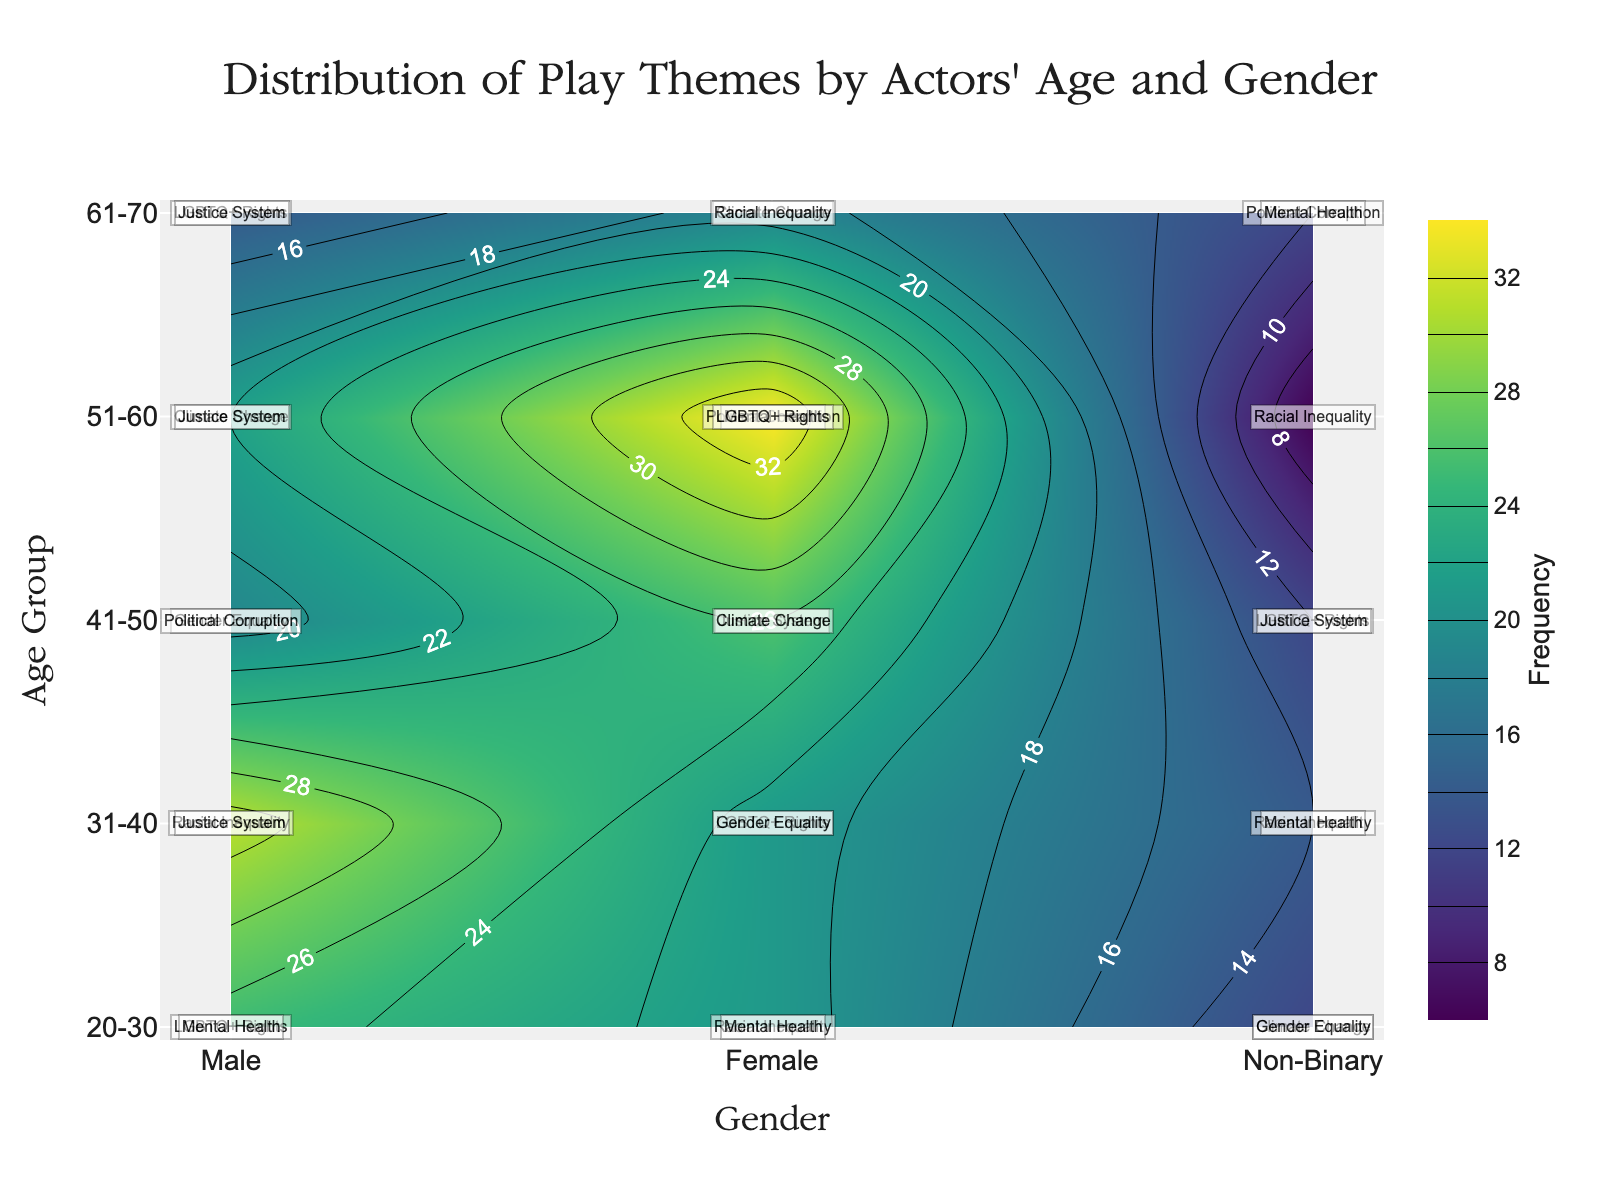What is the title of the plot? The plot title is typically prominently displayed at the top-center of the figure. Based on the provided code, the title is 'Distribution of Play Themes by Actors' Age and Gender'.
Answer: Distribution of Play Themes by Actors' Age and Gender Which age groups are displayed on the y-axis? The y-axis shows the age groups explicitly, which are '20-30', '31-40', '41-50', '51-60', and '61-70'.
Answer: '20-30', '31-40', '41-50', '51-60', '61-70' Which gender has the highest frequency in the '31-40' age group? Looking at the contour plot for the '31-40' age group on the y-axis, the colors represent frequency intensity, and 'Male' (x-axis) should show the brightest color, matching the highest frequency.
Answer: Male What theme is represented by the annotation in the '20-30' age group and 'Non-Binary' gender? The specific annotation for '20-30' age group intersecting with 'Non-Binary' gender would show the theme that is written there. The annotation is 'Climate Change'.
Answer: Climate Change Which theme is the most frequent among 'Female' actors in the '51-60' age group? From the annotations, look at the '51-60' age group for the 'Female' column. The theme with the highest frequency, as per the provided data, will be obvious.
Answer: Political Corruption What is the frequency difference between 'Male' and 'Female' actors within the '41-50' age group? Compare the color intensity or numerical annotations for 'Male' and 'Female' within the '41-50' age group. According to the data, it's (10+9) - (14+12) = 19 - 26 = -7.
Answer: -7 Which gender in the '61-70' age group discusses the 'Political Corruption' theme? Check the '61-70' age group on the y-axis and look for 'Political Corruption' in the annotations. The annotation indicates it's discussed by 'Non-Binary' gender.
Answer: Non-Binary How does the 'Climate Change' theme frequency compare between 'Male' and 'Female' in the '51-60' age group? By referring to the contours and annotations, compare the frequency values. 'Male' has 8 and 'Female' has 9, so Male < Female in this case.
Answer: Female is higher Which gender talks most about 'Racial Inequality' among all age groups? Summing the frequencies for 'Racial Inequality' across all ages per gender, 'Male' = 18 + 6 = 24, 'Female' = 10 + 12 = 22, 'Non-Binary' = 6; hence, 'Male' has the highest sum.
Answer: Male 